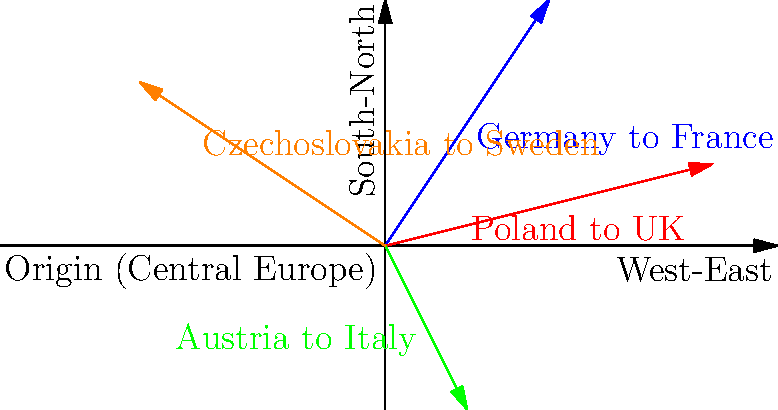Based on the vector representation of refugee movements in Europe during the 1930s, which displacement vector shows the longest distance traveled, and what does this suggest about the refugee crisis of that time? To answer this question, we need to analyze the given vector diagram and follow these steps:

1. Identify the vectors:
   - Blue vector: Germany to France (2,3)
   - Red vector: Poland to UK (4,1)
   - Green vector: Austria to Italy (1,-2)
   - Orange vector: Czechoslovakia to Sweden (-3,2)

2. Calculate the magnitude of each vector using the formula: $\sqrt{x^2 + y^2}$
   - Germany to France: $\sqrt{2^2 + 3^2} = \sqrt{13} \approx 3.61$
   - Poland to UK: $\sqrt{4^2 + 1^2} = \sqrt{17} \approx 4.12$
   - Austria to Italy: $\sqrt{1^2 + (-2)^2} = \sqrt{5} \approx 2.24$
   - Czechoslovakia to Sweden: $\sqrt{(-3)^2 + 2^2} = \sqrt{13} \approx 3.61$

3. Compare the magnitudes:
   The longest vector is Poland to UK (4.12 units).

4. Interpret the result:
   The longest displacement suggests that refugees from Poland traveled the farthest to reach the UK. This implies:
   a) The severity of the situation in Poland, forcing people to flee farther.
   b) The UK's willingness to accept refugees from distant countries.
   c) The complexity of the refugee crisis, involving long-distance movements across Europe.
   d) The impact of geographical and political factors on refugee patterns.

This analysis provides insights into the scale and nature of refugee movements during the 1930s European crisis.
Answer: Poland to UK; indicates severity of Polish situation and UK's refugee acceptance 